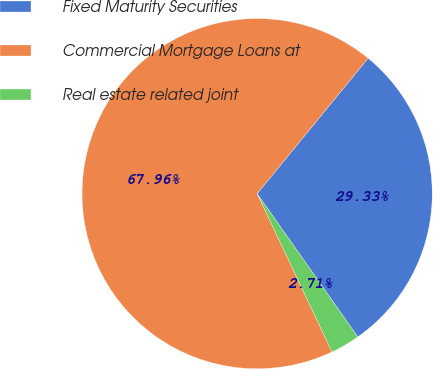Convert chart. <chart><loc_0><loc_0><loc_500><loc_500><pie_chart><fcel>Fixed Maturity Securities<fcel>Commercial Mortgage Loans at<fcel>Real estate related joint<nl><fcel>29.33%<fcel>67.96%<fcel>2.71%<nl></chart> 